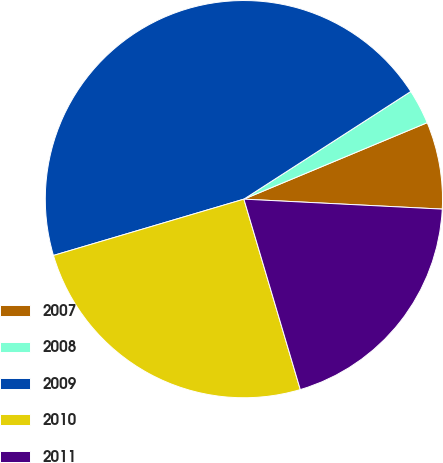<chart> <loc_0><loc_0><loc_500><loc_500><pie_chart><fcel>2007<fcel>2008<fcel>2009<fcel>2010<fcel>2011<nl><fcel>7.09%<fcel>2.83%<fcel>45.46%<fcel>25.01%<fcel>19.62%<nl></chart> 